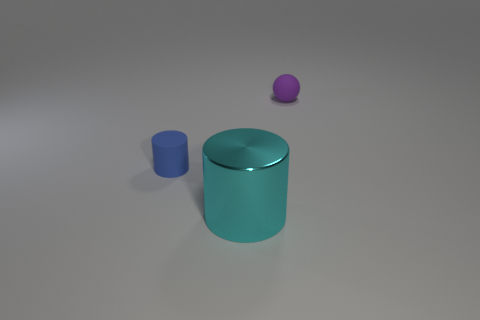Add 3 small blue cubes. How many objects exist? 6 Subtract 1 cylinders. How many cylinders are left? 1 Subtract all cylinders. How many objects are left? 1 Subtract all blue cylinders. Subtract all yellow spheres. How many cylinders are left? 1 Add 1 tiny blue objects. How many tiny blue objects exist? 2 Subtract 1 cyan cylinders. How many objects are left? 2 Subtract all purple balls. How many green cylinders are left? 0 Subtract all cyan things. Subtract all tiny blue things. How many objects are left? 1 Add 2 tiny spheres. How many tiny spheres are left? 3 